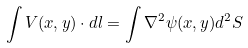Convert formula to latex. <formula><loc_0><loc_0><loc_500><loc_500>\int { V } ( x , y ) \cdot d { l } = \int \nabla ^ { 2 } \psi ( x , y ) d ^ { 2 } S</formula> 